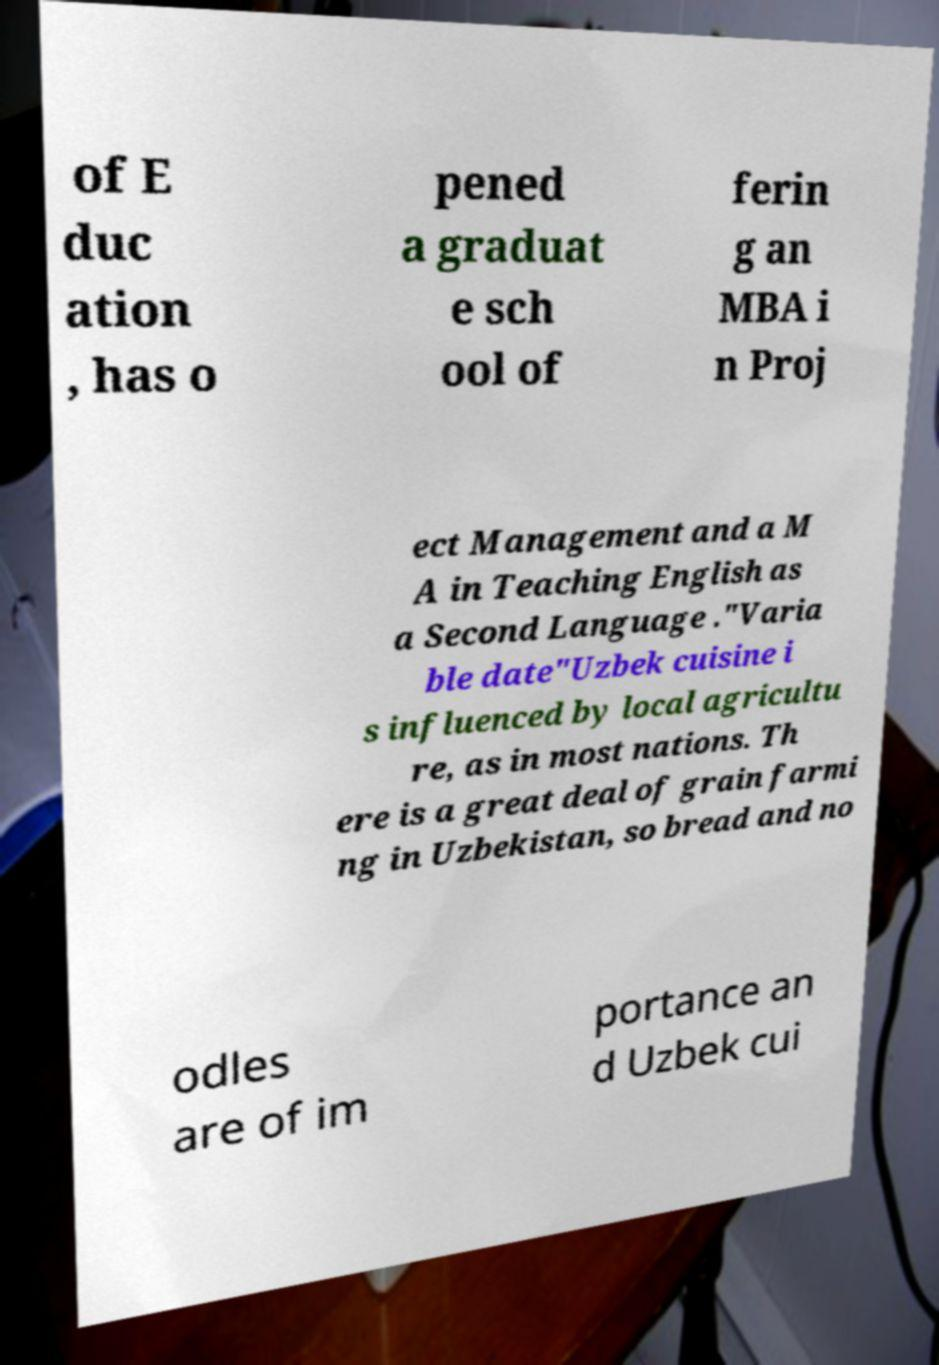Please identify and transcribe the text found in this image. of E duc ation , has o pened a graduat e sch ool of ferin g an MBA i n Proj ect Management and a M A in Teaching English as a Second Language ."Varia ble date"Uzbek cuisine i s influenced by local agricultu re, as in most nations. Th ere is a great deal of grain farmi ng in Uzbekistan, so bread and no odles are of im portance an d Uzbek cui 